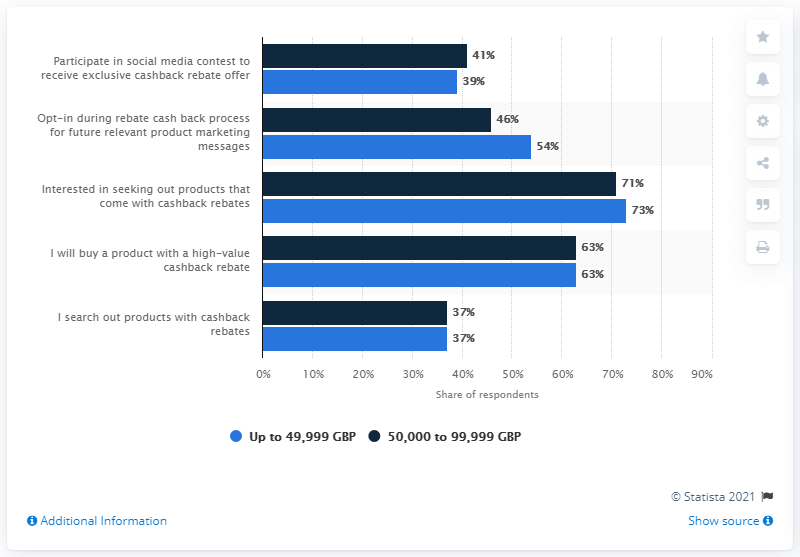Highlight a few significant elements in this photo. The light blue bar indicates a range of up to 49,999 GBP. The number of factors with the same percentage for both up to 49,999 GBP and 50,000 to 99,999 GBP is two. 